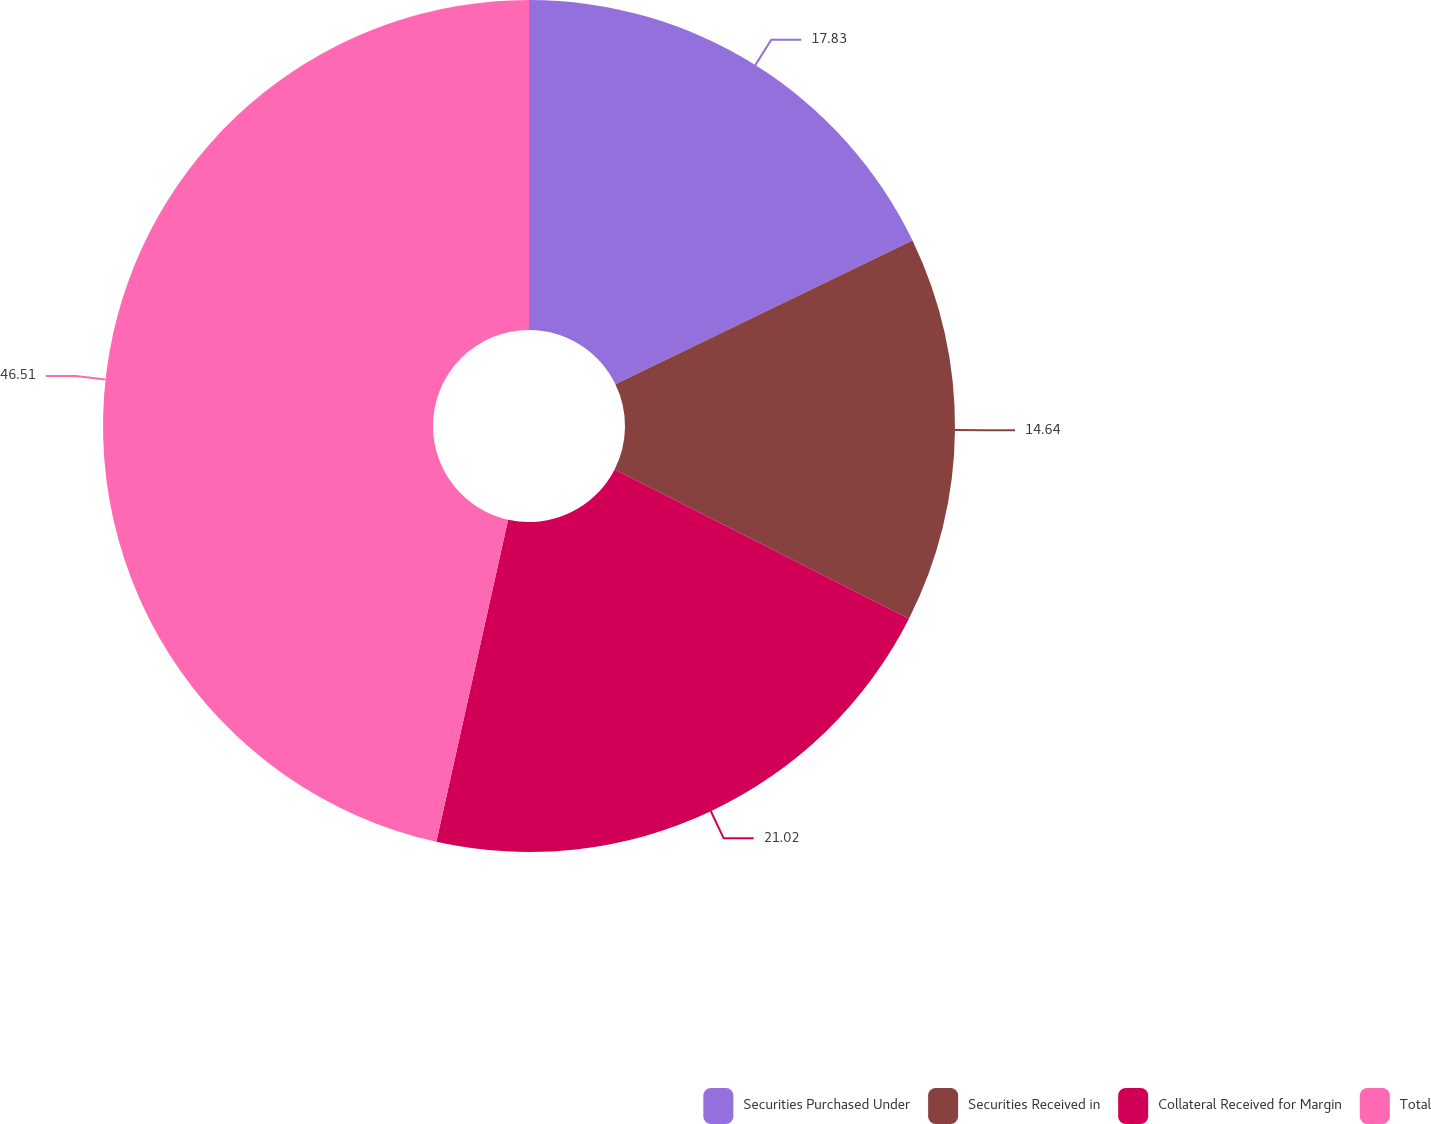Convert chart to OTSL. <chart><loc_0><loc_0><loc_500><loc_500><pie_chart><fcel>Securities Purchased Under<fcel>Securities Received in<fcel>Collateral Received for Margin<fcel>Total<nl><fcel>17.83%<fcel>14.64%<fcel>21.02%<fcel>46.51%<nl></chart> 